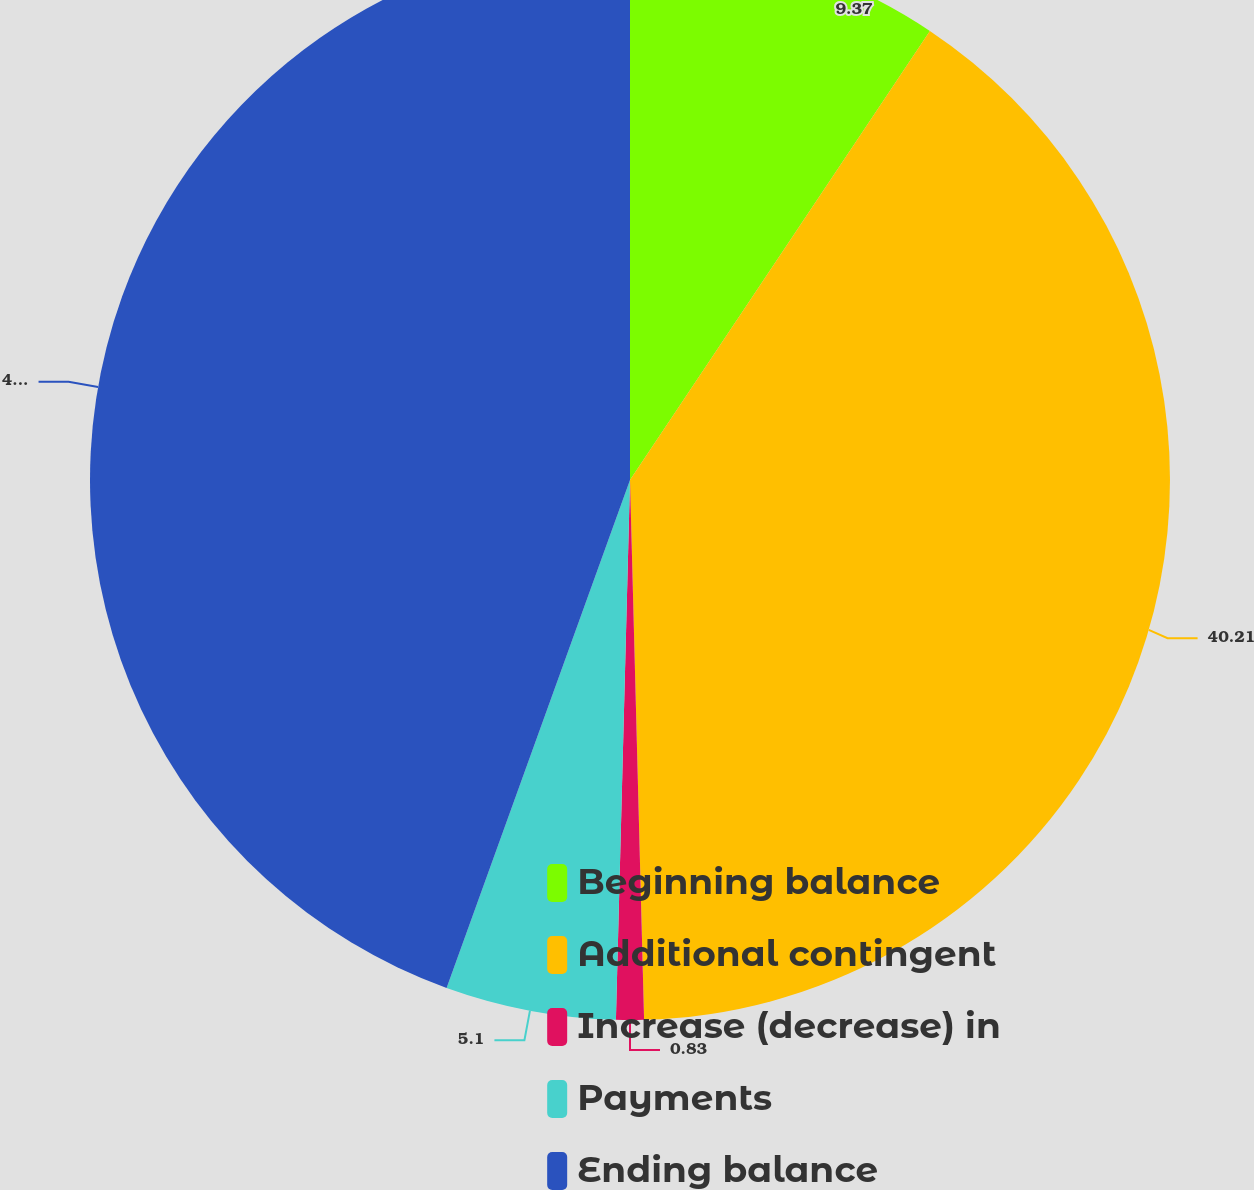Convert chart to OTSL. <chart><loc_0><loc_0><loc_500><loc_500><pie_chart><fcel>Beginning balance<fcel>Additional contingent<fcel>Increase (decrease) in<fcel>Payments<fcel>Ending balance<nl><fcel>9.37%<fcel>40.21%<fcel>0.83%<fcel>5.1%<fcel>44.48%<nl></chart> 